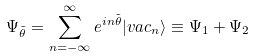Convert formula to latex. <formula><loc_0><loc_0><loc_500><loc_500>\Psi _ { \tilde { \theta } } = \sum _ { n = - \infty } ^ { \infty } e ^ { i n \tilde { \theta } } | v a c _ { n } \rangle \equiv \Psi _ { 1 } + \Psi _ { 2 }</formula> 